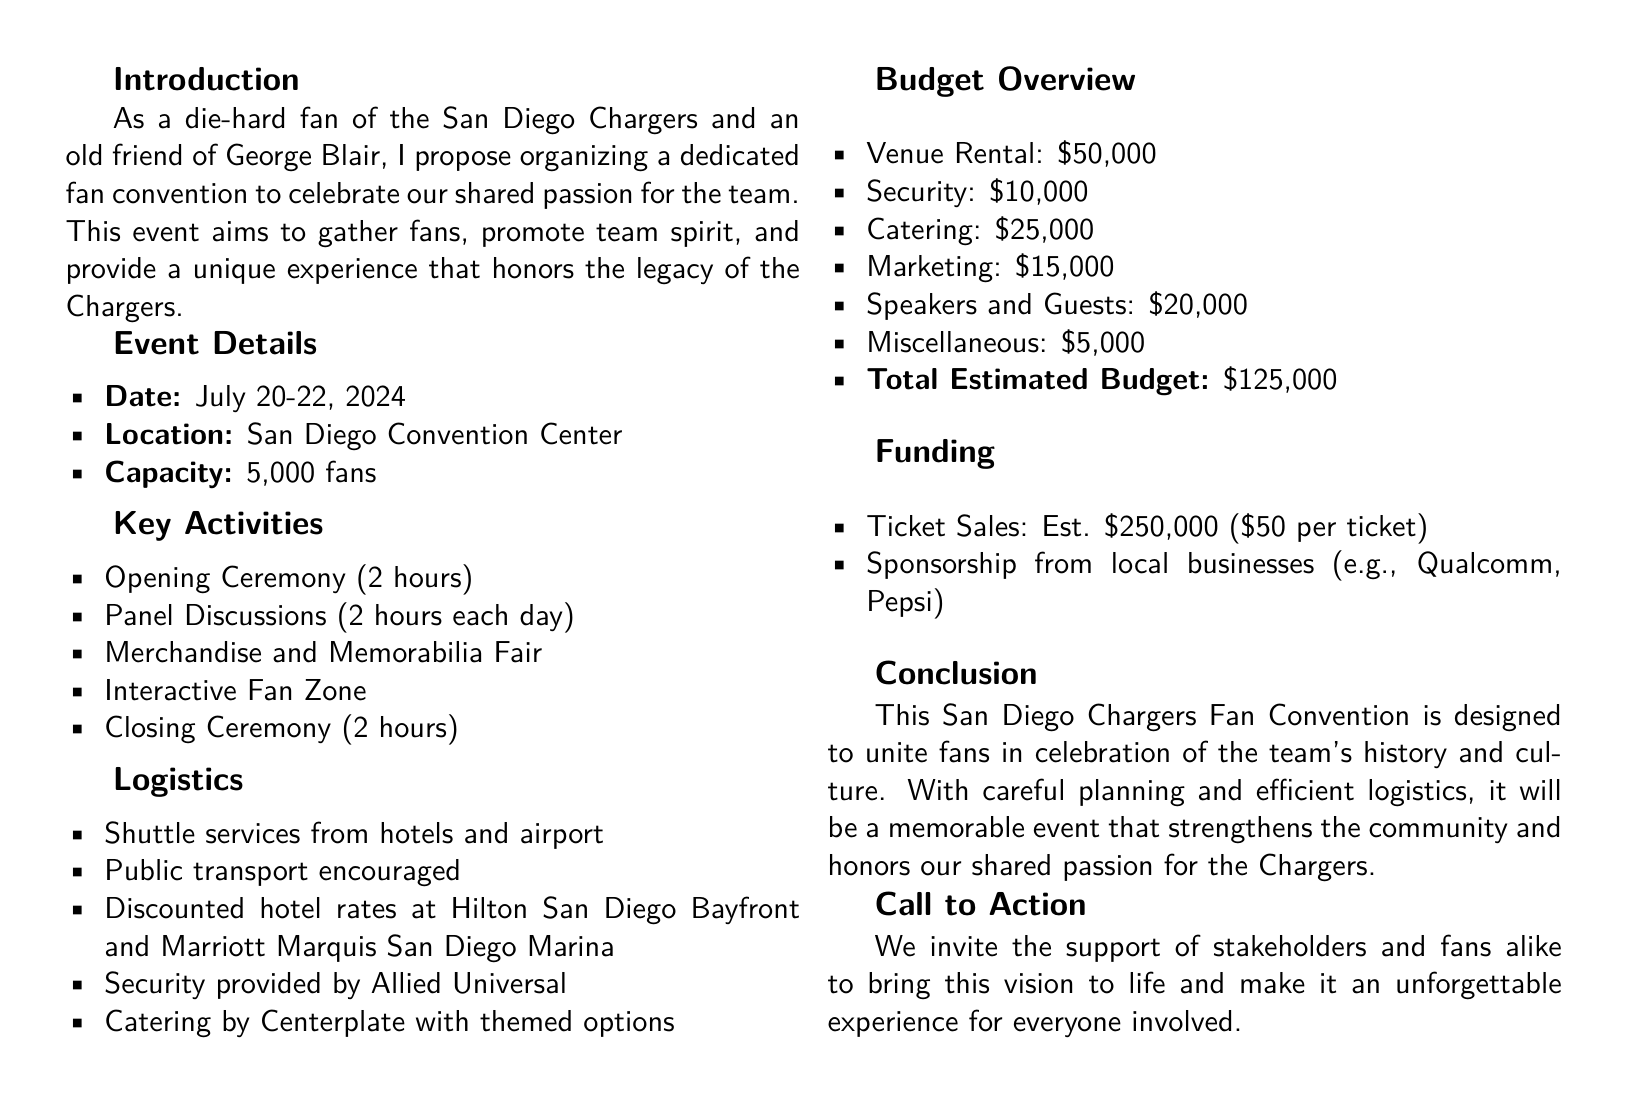What is the event date? The event date is specified in the document and says July 20-22, 2024.
Answer: July 20-22, 2024 What is the venue location? The venue location is mentioned in the proposal as the San Diego Convention Center.
Answer: San Diego Convention Center What is the estimated total budget? The total budget is listed in the document as $125,000.
Answer: $125,000 How many fans can attend? The document states that the capacity for the event is 5,000 fans.
Answer: 5,000 fans What is the catering budget? The budget for catering is provided in the overview and is $25,000.
Answer: $25,000 What type of activities are included? The proposal lists several activities, one being the Opening Ceremony, indicating a focus on celebrating Chargers fans.
Answer: Opening Ceremony What is the projected revenue from ticket sales? The document states that the estimated revenue from ticket sales is $250,000.
Answer: $250,000 What are the security arrangements? Security is mentioned to be provided by Allied Universal in the logistics section.
Answer: Allied Universal What is the purpose of the convention? The purpose is stated as uniting fans to celebrate the team's history and culture.
Answer: Unite fans 